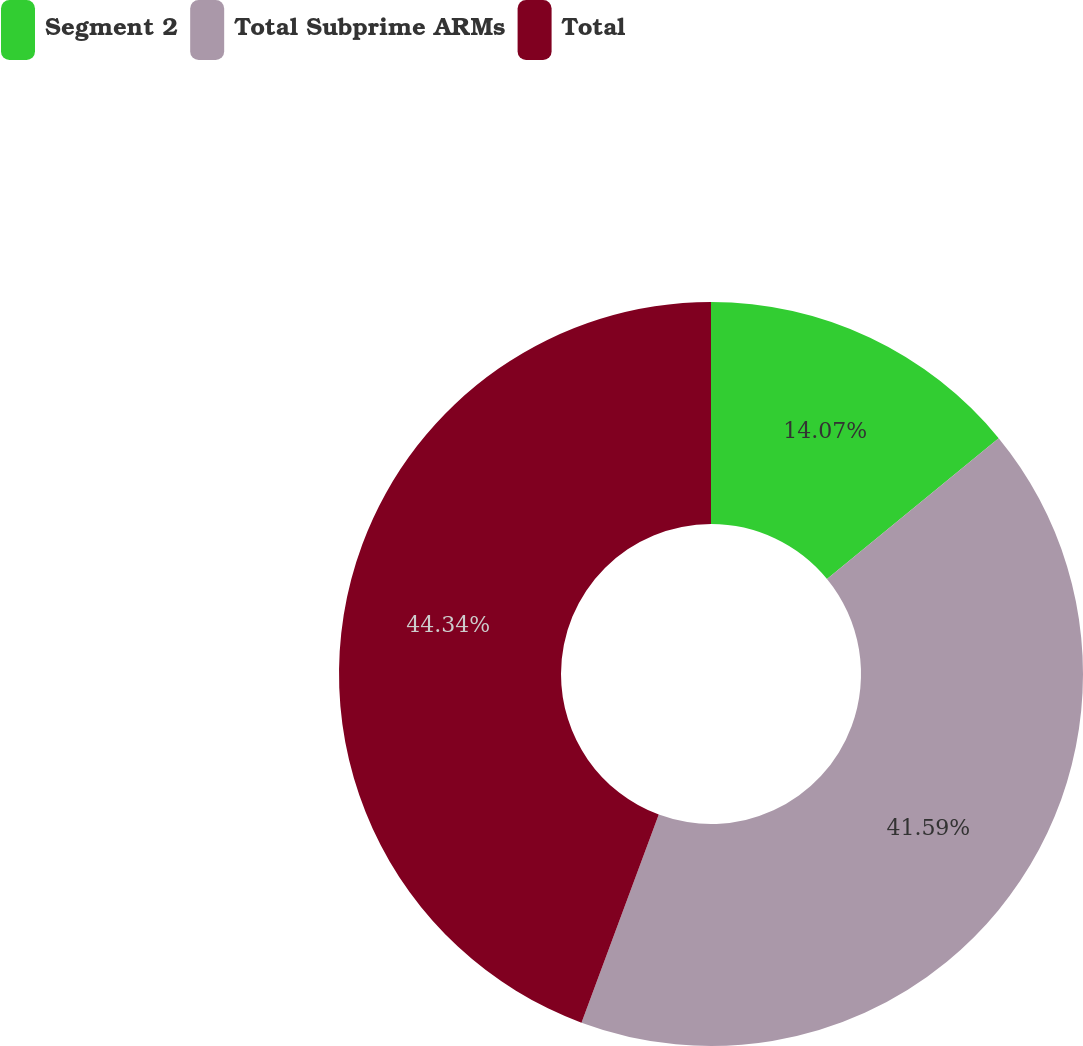Convert chart to OTSL. <chart><loc_0><loc_0><loc_500><loc_500><pie_chart><fcel>Segment 2<fcel>Total Subprime ARMs<fcel>Total<nl><fcel>14.07%<fcel>41.59%<fcel>44.34%<nl></chart> 